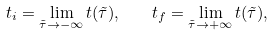<formula> <loc_0><loc_0><loc_500><loc_500>t _ { i } = \lim _ { \tilde { \tau } \to - \infty } t ( \tilde { \tau } ) , \quad t _ { f } = \lim _ { \tilde { \tau } \to + \infty } t ( \tilde { \tau } ) ,</formula> 